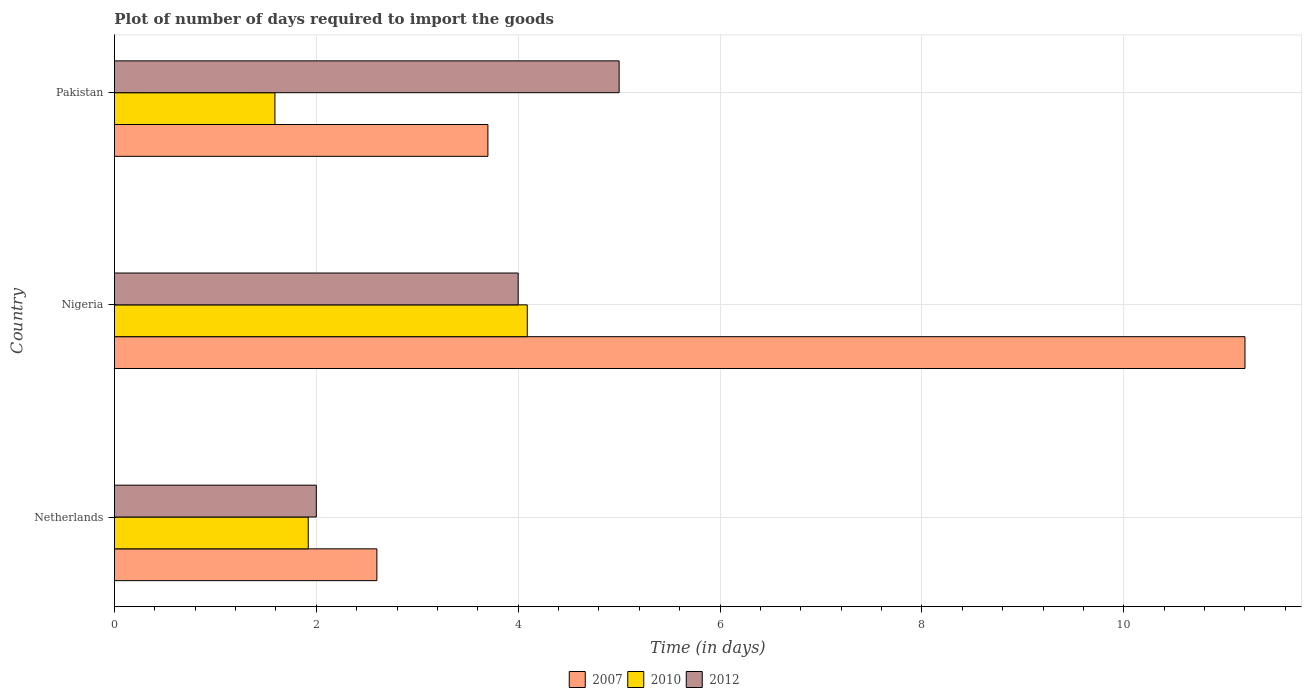How many different coloured bars are there?
Offer a terse response. 3. How many groups of bars are there?
Your answer should be compact. 3. Are the number of bars per tick equal to the number of legend labels?
Provide a succinct answer. Yes. Are the number of bars on each tick of the Y-axis equal?
Provide a succinct answer. Yes. How many bars are there on the 1st tick from the bottom?
Make the answer very short. 3. What is the label of the 1st group of bars from the top?
Make the answer very short. Pakistan. In how many cases, is the number of bars for a given country not equal to the number of legend labels?
Your answer should be very brief. 0. What is the time required to import goods in 2010 in Netherlands?
Your answer should be very brief. 1.92. Across all countries, what is the maximum time required to import goods in 2010?
Your answer should be very brief. 4.09. Across all countries, what is the minimum time required to import goods in 2010?
Give a very brief answer. 1.59. In which country was the time required to import goods in 2010 maximum?
Give a very brief answer. Nigeria. What is the difference between the time required to import goods in 2007 in Netherlands and that in Nigeria?
Ensure brevity in your answer.  -8.6. What is the difference between the time required to import goods in 2010 in Netherlands and the time required to import goods in 2012 in Nigeria?
Your answer should be compact. -2.08. What is the average time required to import goods in 2010 per country?
Provide a succinct answer. 2.53. What is the difference between the time required to import goods in 2010 and time required to import goods in 2007 in Nigeria?
Provide a succinct answer. -7.11. In how many countries, is the time required to import goods in 2010 greater than 2.8 days?
Ensure brevity in your answer.  1. What is the ratio of the time required to import goods in 2007 in Nigeria to that in Pakistan?
Offer a very short reply. 3.03. Is the time required to import goods in 2012 in Nigeria less than that in Pakistan?
Provide a short and direct response. Yes. What is the difference between the highest and the second highest time required to import goods in 2007?
Ensure brevity in your answer.  7.5. In how many countries, is the time required to import goods in 2012 greater than the average time required to import goods in 2012 taken over all countries?
Provide a short and direct response. 2. Are all the bars in the graph horizontal?
Your answer should be compact. Yes. Does the graph contain any zero values?
Make the answer very short. No. Where does the legend appear in the graph?
Ensure brevity in your answer.  Bottom center. How are the legend labels stacked?
Keep it short and to the point. Horizontal. What is the title of the graph?
Your answer should be very brief. Plot of number of days required to import the goods. Does "1985" appear as one of the legend labels in the graph?
Offer a very short reply. No. What is the label or title of the X-axis?
Your response must be concise. Time (in days). What is the Time (in days) in 2007 in Netherlands?
Provide a short and direct response. 2.6. What is the Time (in days) in 2010 in Netherlands?
Give a very brief answer. 1.92. What is the Time (in days) of 2012 in Netherlands?
Your response must be concise. 2. What is the Time (in days) in 2010 in Nigeria?
Give a very brief answer. 4.09. What is the Time (in days) of 2012 in Nigeria?
Ensure brevity in your answer.  4. What is the Time (in days) of 2007 in Pakistan?
Ensure brevity in your answer.  3.7. What is the Time (in days) of 2010 in Pakistan?
Your response must be concise. 1.59. Across all countries, what is the maximum Time (in days) in 2007?
Ensure brevity in your answer.  11.2. Across all countries, what is the maximum Time (in days) in 2010?
Ensure brevity in your answer.  4.09. Across all countries, what is the maximum Time (in days) of 2012?
Make the answer very short. 5. Across all countries, what is the minimum Time (in days) of 2007?
Make the answer very short. 2.6. Across all countries, what is the minimum Time (in days) of 2010?
Offer a very short reply. 1.59. What is the total Time (in days) of 2007 in the graph?
Give a very brief answer. 17.5. What is the total Time (in days) in 2010 in the graph?
Keep it short and to the point. 7.6. What is the difference between the Time (in days) in 2007 in Netherlands and that in Nigeria?
Offer a terse response. -8.6. What is the difference between the Time (in days) in 2010 in Netherlands and that in Nigeria?
Your response must be concise. -2.17. What is the difference between the Time (in days) in 2012 in Netherlands and that in Nigeria?
Your answer should be very brief. -2. What is the difference between the Time (in days) of 2007 in Netherlands and that in Pakistan?
Offer a terse response. -1.1. What is the difference between the Time (in days) in 2010 in Netherlands and that in Pakistan?
Your answer should be compact. 0.33. What is the difference between the Time (in days) in 2012 in Netherlands and that in Pakistan?
Provide a succinct answer. -3. What is the difference between the Time (in days) of 2012 in Nigeria and that in Pakistan?
Give a very brief answer. -1. What is the difference between the Time (in days) in 2007 in Netherlands and the Time (in days) in 2010 in Nigeria?
Give a very brief answer. -1.49. What is the difference between the Time (in days) in 2010 in Netherlands and the Time (in days) in 2012 in Nigeria?
Provide a succinct answer. -2.08. What is the difference between the Time (in days) in 2007 in Netherlands and the Time (in days) in 2010 in Pakistan?
Your response must be concise. 1.01. What is the difference between the Time (in days) in 2010 in Netherlands and the Time (in days) in 2012 in Pakistan?
Your answer should be very brief. -3.08. What is the difference between the Time (in days) of 2007 in Nigeria and the Time (in days) of 2010 in Pakistan?
Offer a very short reply. 9.61. What is the difference between the Time (in days) in 2010 in Nigeria and the Time (in days) in 2012 in Pakistan?
Your answer should be compact. -0.91. What is the average Time (in days) in 2007 per country?
Give a very brief answer. 5.83. What is the average Time (in days) in 2010 per country?
Provide a succinct answer. 2.53. What is the average Time (in days) in 2012 per country?
Provide a succinct answer. 3.67. What is the difference between the Time (in days) in 2007 and Time (in days) in 2010 in Netherlands?
Give a very brief answer. 0.68. What is the difference between the Time (in days) in 2007 and Time (in days) in 2012 in Netherlands?
Provide a succinct answer. 0.6. What is the difference between the Time (in days) of 2010 and Time (in days) of 2012 in Netherlands?
Your answer should be compact. -0.08. What is the difference between the Time (in days) in 2007 and Time (in days) in 2010 in Nigeria?
Your response must be concise. 7.11. What is the difference between the Time (in days) in 2007 and Time (in days) in 2012 in Nigeria?
Your response must be concise. 7.2. What is the difference between the Time (in days) of 2010 and Time (in days) of 2012 in Nigeria?
Keep it short and to the point. 0.09. What is the difference between the Time (in days) of 2007 and Time (in days) of 2010 in Pakistan?
Your answer should be compact. 2.11. What is the difference between the Time (in days) in 2010 and Time (in days) in 2012 in Pakistan?
Provide a succinct answer. -3.41. What is the ratio of the Time (in days) of 2007 in Netherlands to that in Nigeria?
Ensure brevity in your answer.  0.23. What is the ratio of the Time (in days) of 2010 in Netherlands to that in Nigeria?
Make the answer very short. 0.47. What is the ratio of the Time (in days) in 2007 in Netherlands to that in Pakistan?
Your answer should be compact. 0.7. What is the ratio of the Time (in days) in 2010 in Netherlands to that in Pakistan?
Ensure brevity in your answer.  1.21. What is the ratio of the Time (in days) in 2007 in Nigeria to that in Pakistan?
Provide a short and direct response. 3.03. What is the ratio of the Time (in days) in 2010 in Nigeria to that in Pakistan?
Your answer should be compact. 2.57. What is the difference between the highest and the second highest Time (in days) of 2010?
Give a very brief answer. 2.17. 